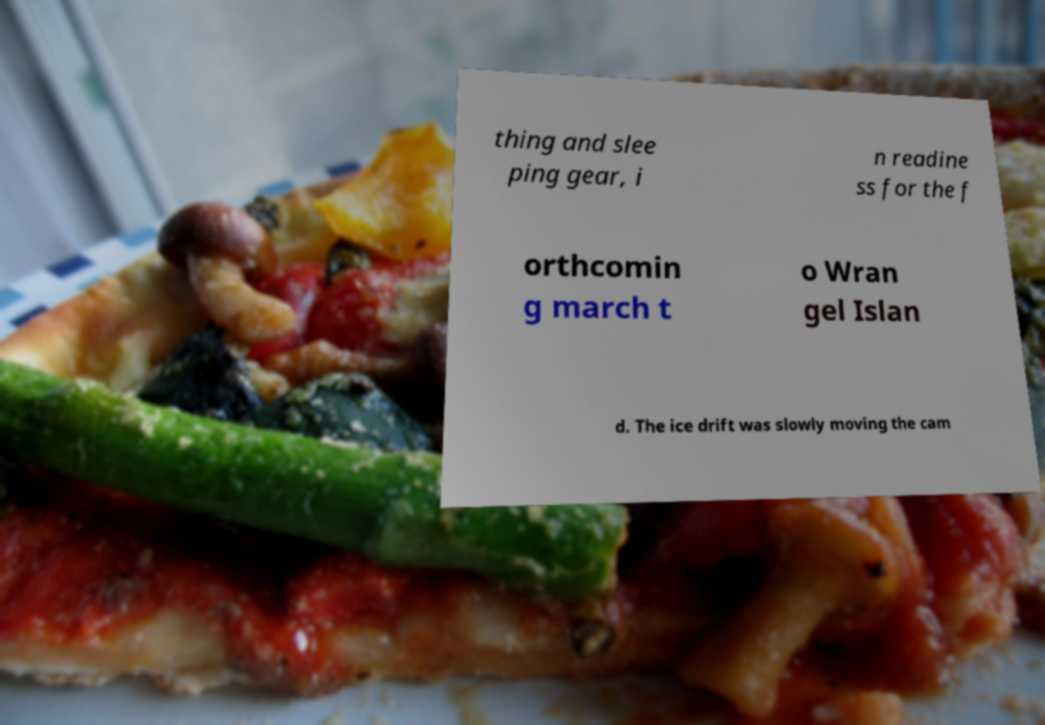Could you extract and type out the text from this image? thing and slee ping gear, i n readine ss for the f orthcomin g march t o Wran gel Islan d. The ice drift was slowly moving the cam 